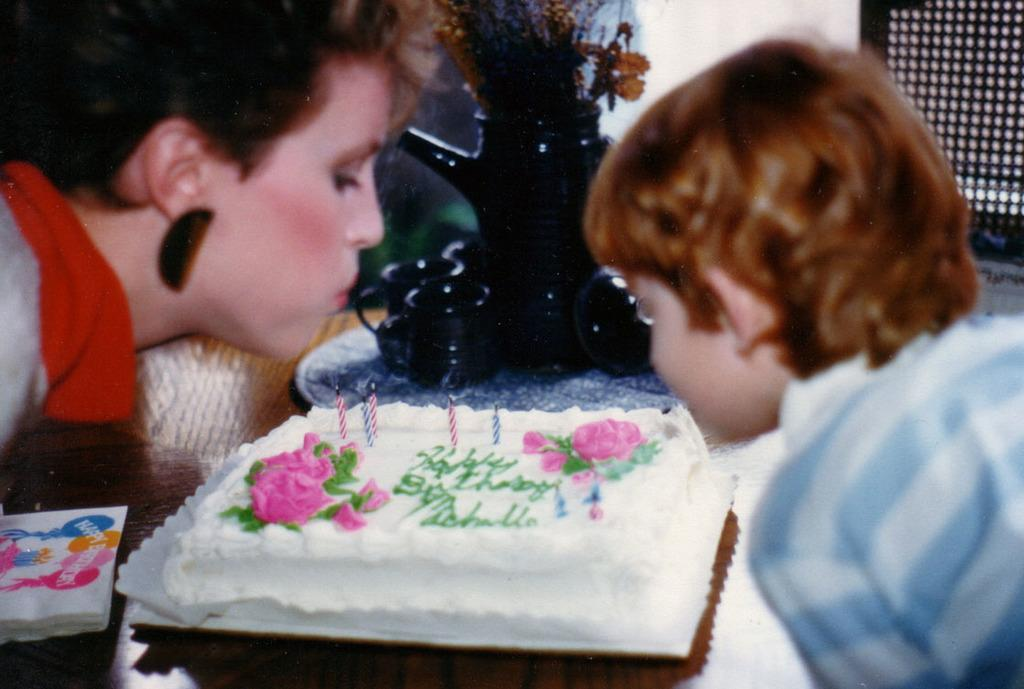How many people are in the image? There are two persons standing in the image. Where are the persons located in the image? The persons are in the middle of the image. What is behind the persons in the image? There is a table behind the persons. What is on the table in the image? There is a cake and a paper on the table. What type of cork can be seen on the bedroom wall in the image? There is no cork or bedroom present in the image; it features two persons standing with a table behind them, on which there is a cake and a paper. 